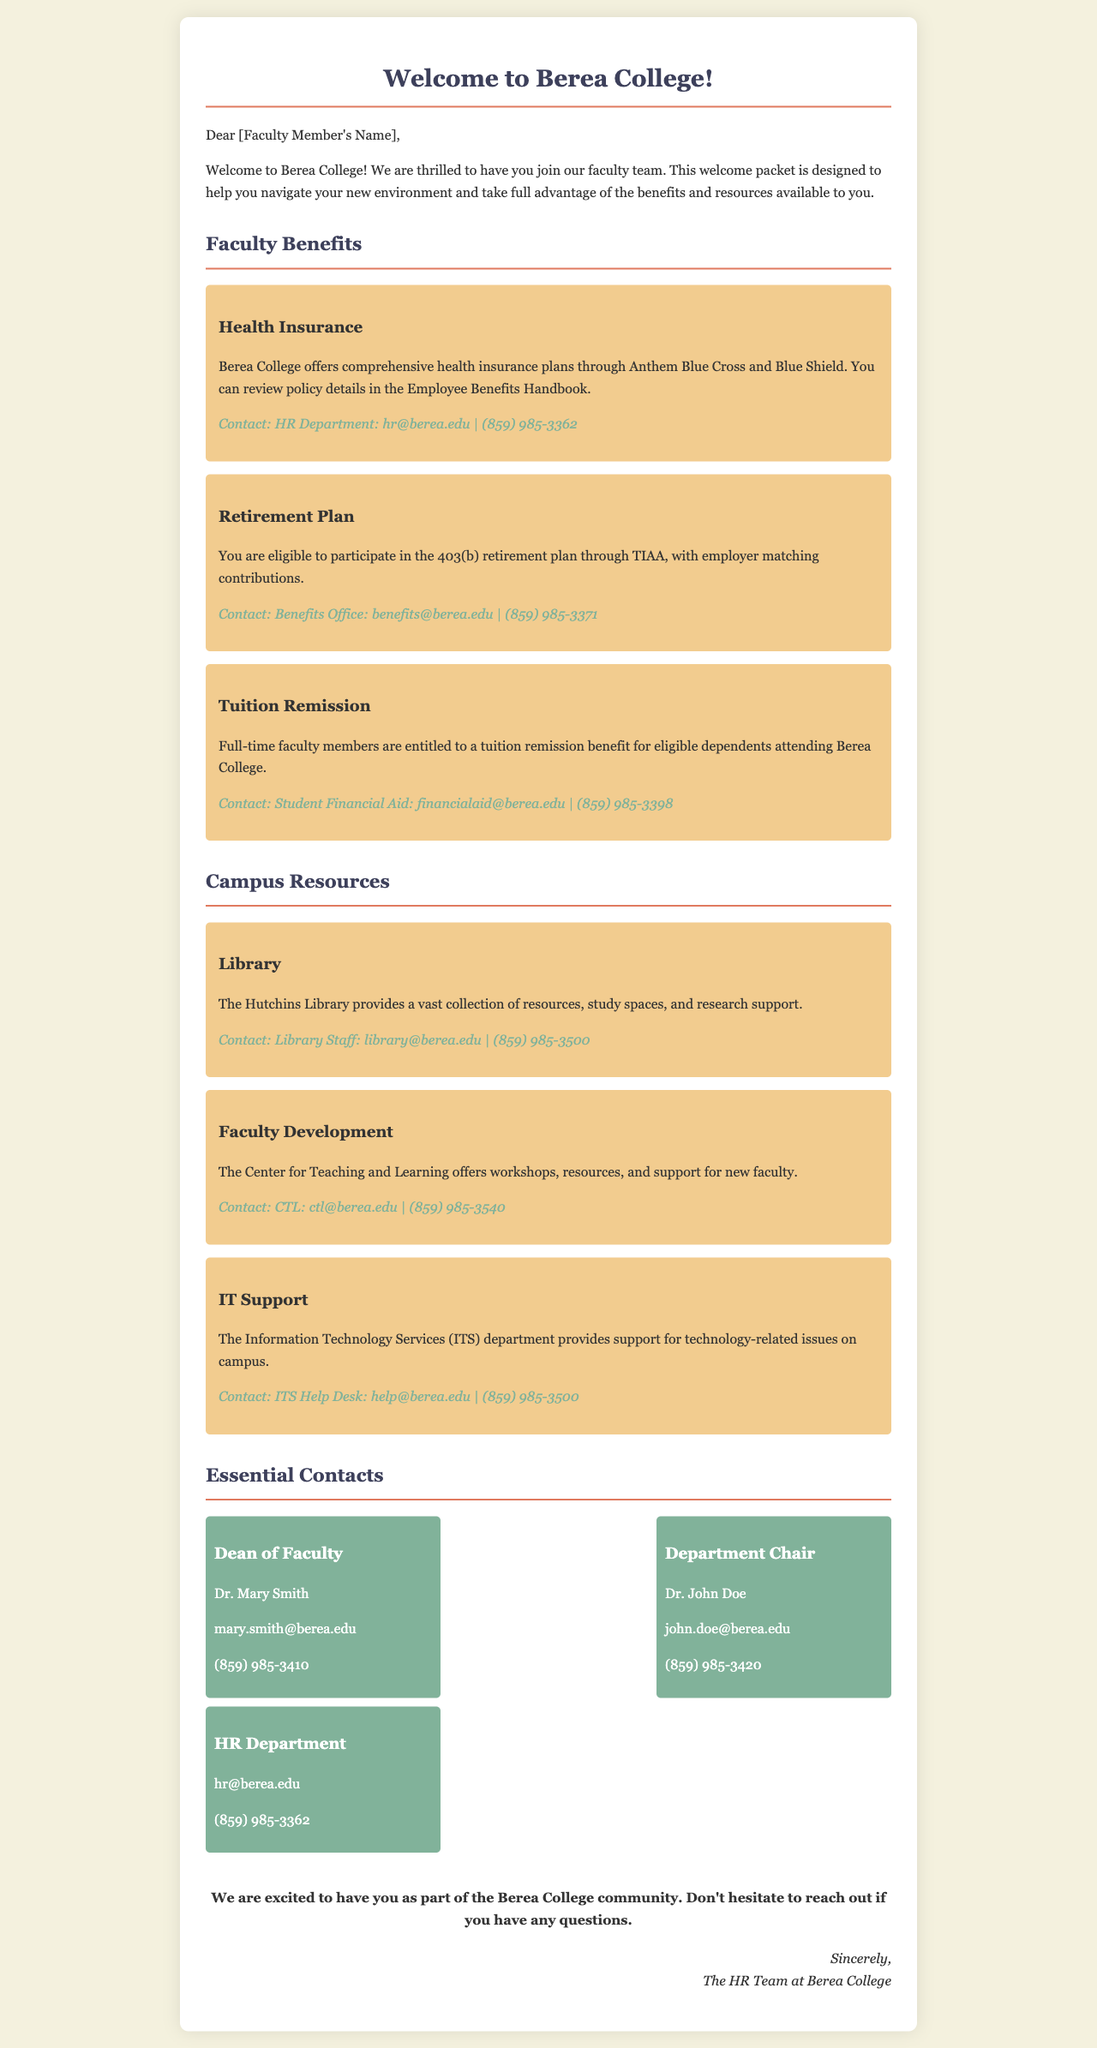What health insurance company is mentioned? The health insurance plan details are provided through Anthem Blue Cross and Blue Shield.
Answer: Anthem Blue Cross and Blue Shield Who is the Dean of Faculty? The document lists the name and contact details of the Dean of Faculty.
Answer: Dr. Mary Smith What benefit do full-time faculty members receive for their dependents? The document states the benefit available to full-time faculty members regarding tuition.
Answer: Tuition remission What services does the Center for Teaching and Learning provide? The document describes the offerings of the Center for Teaching and Learning, highlighting various forms of support.
Answer: Workshops, resources, and support for new faculty How many essential contacts are listed? The document displays three essential contacts in the specified section.
Answer: Three What is the main purpose of this welcome packet? The introduction of the document emphasizes the goal of helping new faculty navigate their new environment.
Answer: Helping new faculty navigate their new environment Which department assists with technology-related issues? The document specifically mentions the service area for technology support.
Answer: Information Technology Services (ITS) 